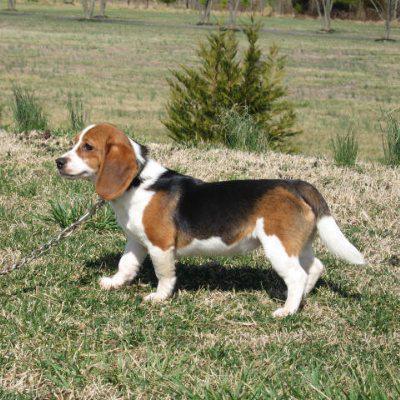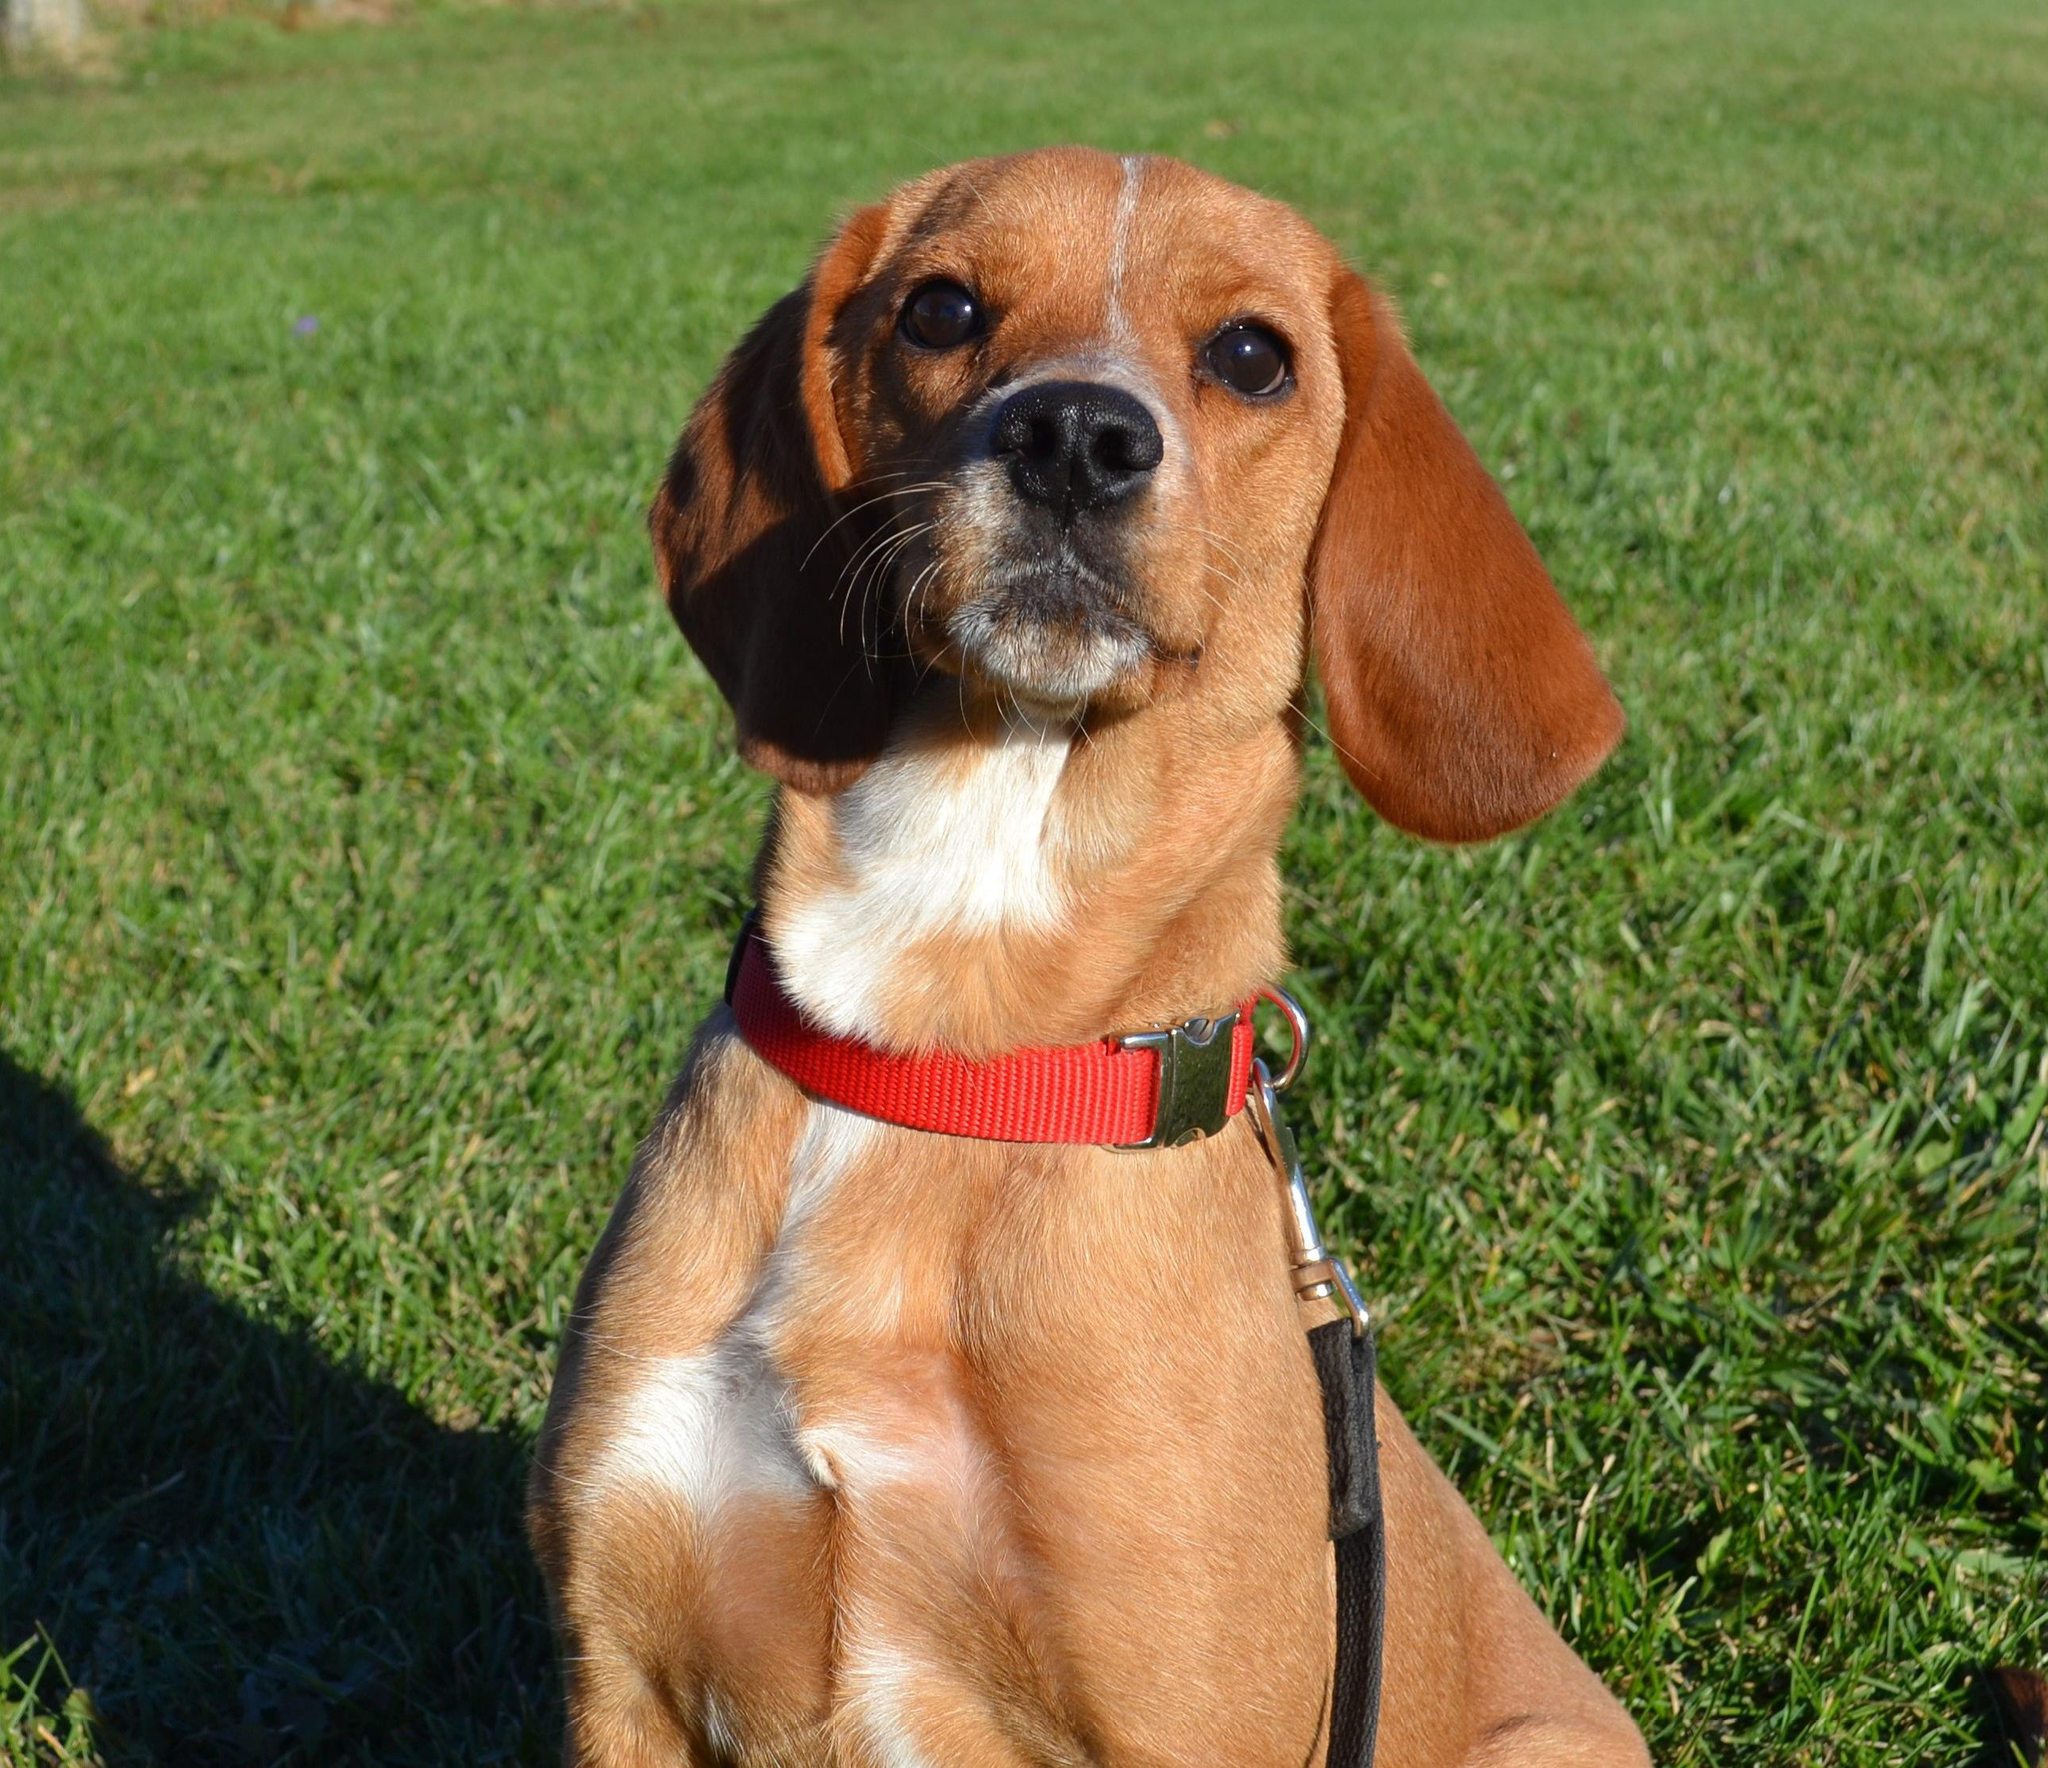The first image is the image on the left, the second image is the image on the right. Assess this claim about the two images: "dogs have ears flapping while they run". Correct or not? Answer yes or no. No. The first image is the image on the left, the second image is the image on the right. For the images shown, is this caption "At least one of the dogs in one of the images has a horizontal or vertical ear position that is not flopped downwards." true? Answer yes or no. No. 